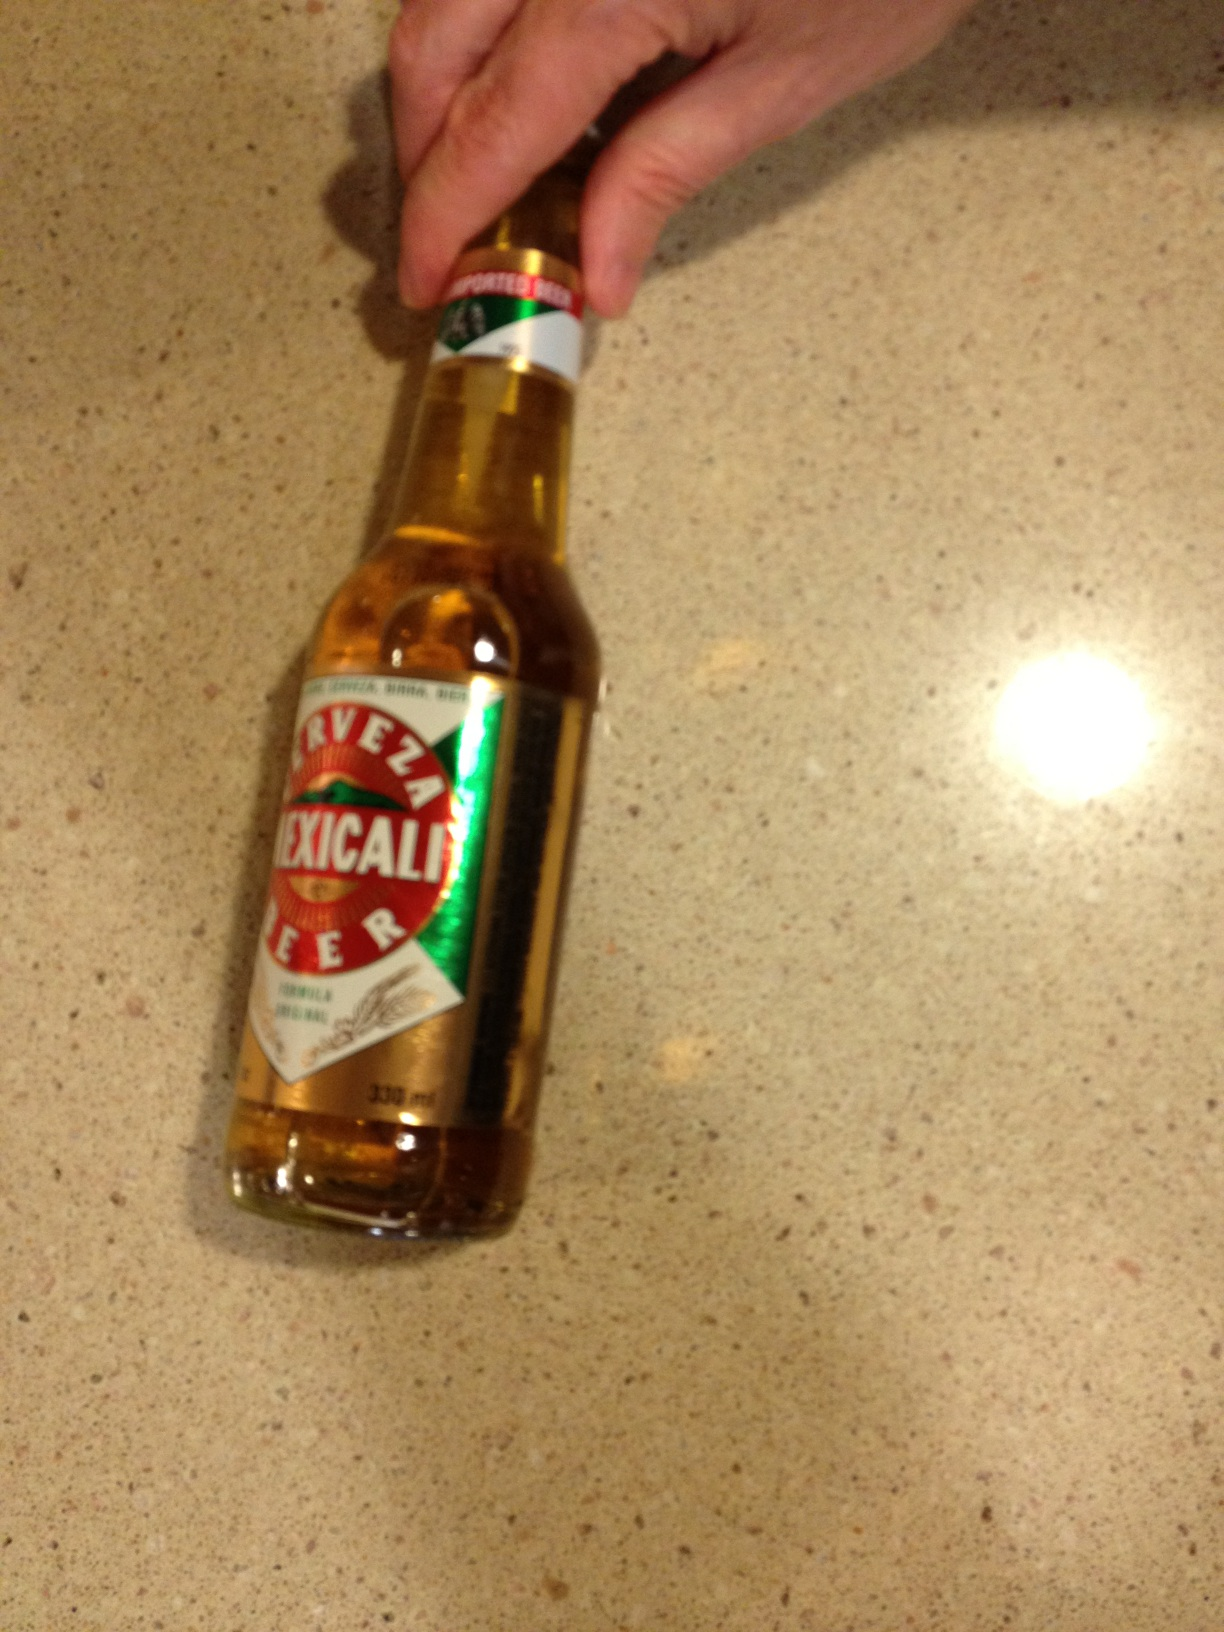Can you describe the taste profile of this beer? Mexicali beer is known for its crisp and refreshing taste, with a great balance between malts and hops, yeasty notes, and a clean finish that makes it perfect for a hot day. 